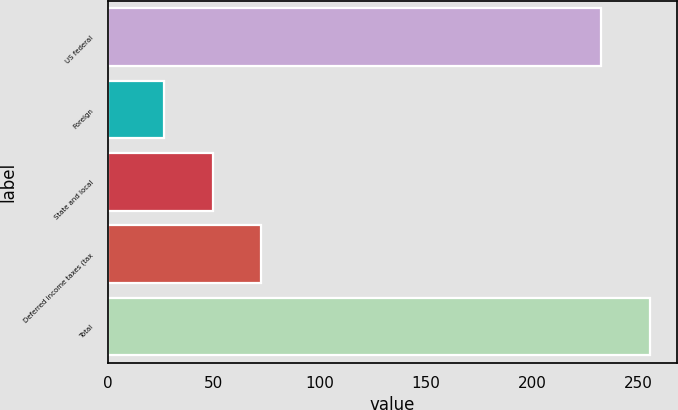Convert chart to OTSL. <chart><loc_0><loc_0><loc_500><loc_500><bar_chart><fcel>US federal<fcel>Foreign<fcel>State and local<fcel>Deferred income taxes (tax<fcel>Total<nl><fcel>232.5<fcel>26.5<fcel>49.38<fcel>72.26<fcel>255.38<nl></chart> 